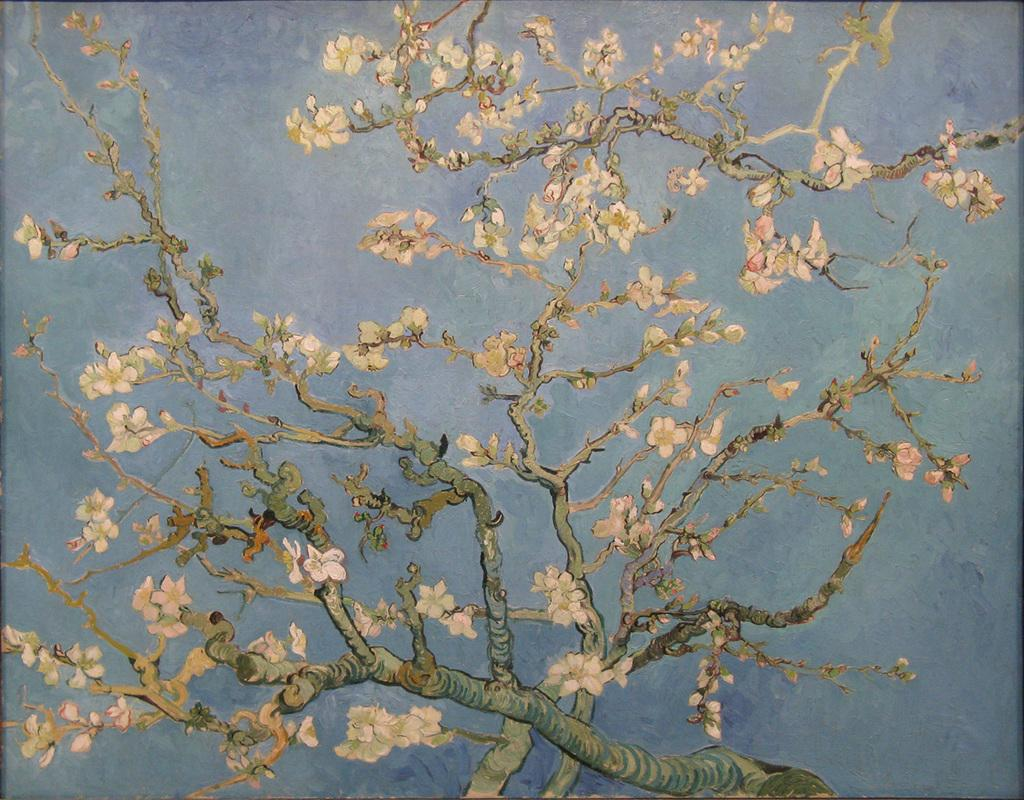What is the main subject of the image? There is a painting in the image. What is depicted in the painting? The painting depicts a tree. Are there any specific features of the tree in the painting? Yes, the tree has flowers on it. How many roses can be seen growing on the tree in the image? There are no roses present in the image; the tree has flowers, but they are not specified as roses. What angle is the tree depicted at in the painting? The angle at which the tree is depicted cannot be determined from the image, as it is a two-dimensional representation. 